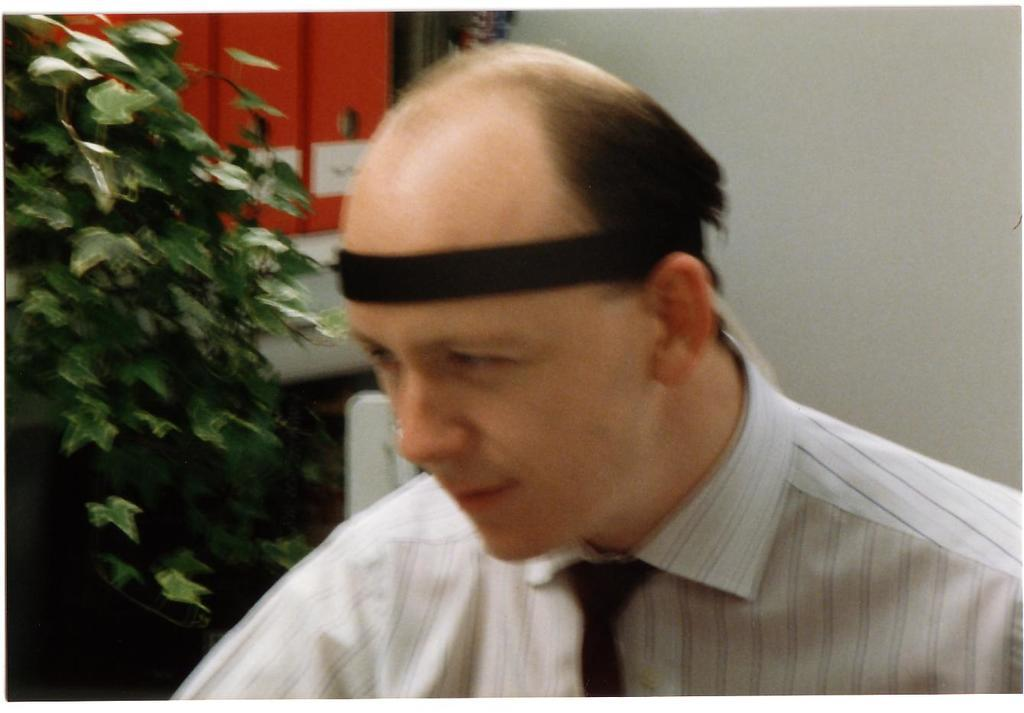Who is present in the image? There is a man in the image. What can be seen on the left side of the image? There is a tree on the left side of the image. What is visible in the background of the image? There is a wall in the background of the image. What type of steam is coming out of the man's ears in the image? There is no steam coming out of the man's ears in the image; it is not present. 